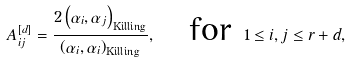<formula> <loc_0><loc_0><loc_500><loc_500>A ^ { [ d ] } _ { i j } = \frac { 2 \left ( \alpha _ { i } , \alpha _ { j } \right ) _ { \text {Killing} } } { \left ( \alpha _ { i } , \alpha _ { i } \right ) _ { \text {Killing} } } , \quad \text {for } 1 \leq i , j \leq r + d ,</formula> 